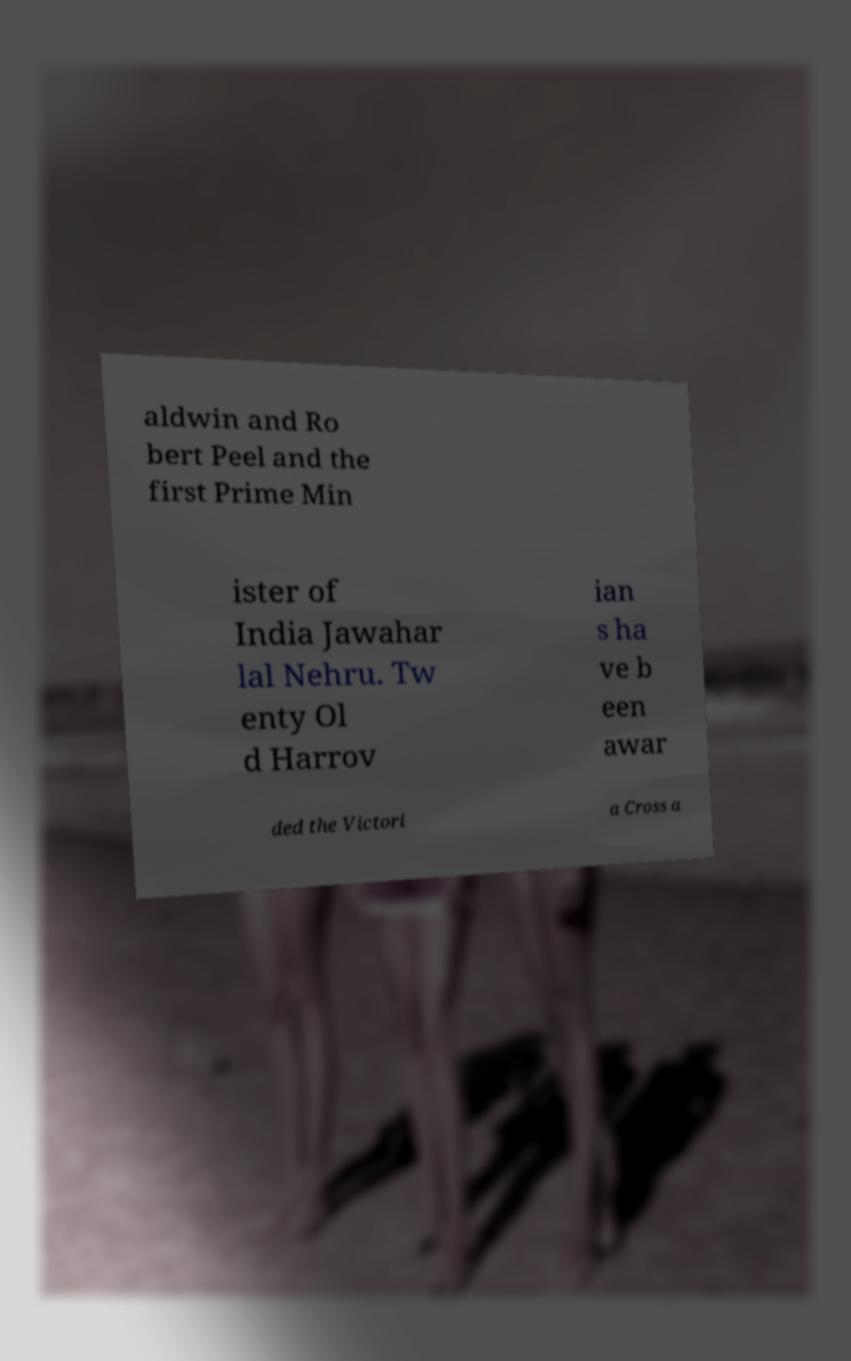Please read and relay the text visible in this image. What does it say? aldwin and Ro bert Peel and the first Prime Min ister of India Jawahar lal Nehru. Tw enty Ol d Harrov ian s ha ve b een awar ded the Victori a Cross a 